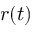Convert formula to latex. <formula><loc_0><loc_0><loc_500><loc_500>r ( t )</formula> 